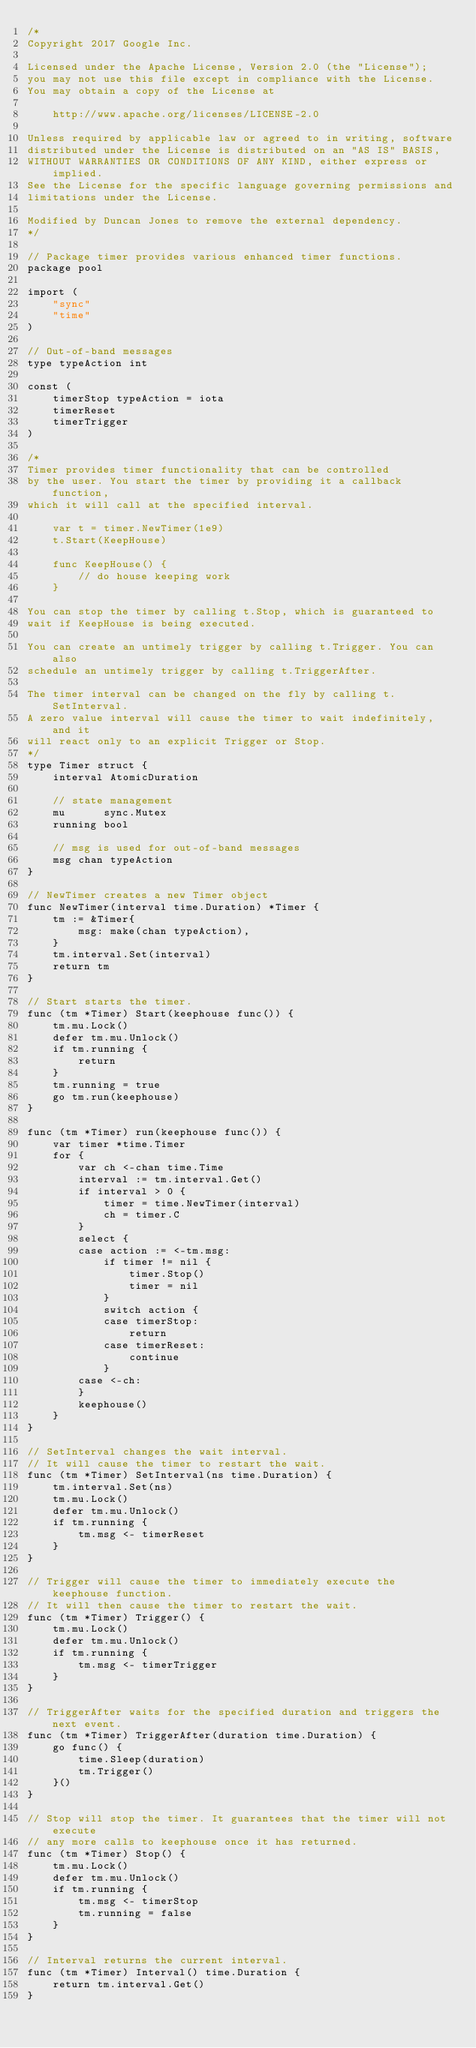<code> <loc_0><loc_0><loc_500><loc_500><_Go_>/*
Copyright 2017 Google Inc.

Licensed under the Apache License, Version 2.0 (the "License");
you may not use this file except in compliance with the License.
You may obtain a copy of the License at

    http://www.apache.org/licenses/LICENSE-2.0

Unless required by applicable law or agreed to in writing, software
distributed under the License is distributed on an "AS IS" BASIS,
WITHOUT WARRANTIES OR CONDITIONS OF ANY KIND, either express or implied.
See the License for the specific language governing permissions and
limitations under the License.

Modified by Duncan Jones to remove the external dependency.
*/

// Package timer provides various enhanced timer functions.
package pool

import (
	"sync"
	"time"
)

// Out-of-band messages
type typeAction int

const (
	timerStop typeAction = iota
	timerReset
	timerTrigger
)

/*
Timer provides timer functionality that can be controlled
by the user. You start the timer by providing it a callback function,
which it will call at the specified interval.

	var t = timer.NewTimer(1e9)
	t.Start(KeepHouse)

	func KeepHouse() {
		// do house keeping work
	}

You can stop the timer by calling t.Stop, which is guaranteed to
wait if KeepHouse is being executed.

You can create an untimely trigger by calling t.Trigger. You can also
schedule an untimely trigger by calling t.TriggerAfter.

The timer interval can be changed on the fly by calling t.SetInterval.
A zero value interval will cause the timer to wait indefinitely, and it
will react only to an explicit Trigger or Stop.
*/
type Timer struct {
	interval AtomicDuration

	// state management
	mu      sync.Mutex
	running bool

	// msg is used for out-of-band messages
	msg chan typeAction
}

// NewTimer creates a new Timer object
func NewTimer(interval time.Duration) *Timer {
	tm := &Timer{
		msg: make(chan typeAction),
	}
	tm.interval.Set(interval)
	return tm
}

// Start starts the timer.
func (tm *Timer) Start(keephouse func()) {
	tm.mu.Lock()
	defer tm.mu.Unlock()
	if tm.running {
		return
	}
	tm.running = true
	go tm.run(keephouse)
}

func (tm *Timer) run(keephouse func()) {
	var timer *time.Timer
	for {
		var ch <-chan time.Time
		interval := tm.interval.Get()
		if interval > 0 {
			timer = time.NewTimer(interval)
			ch = timer.C
		}
		select {
		case action := <-tm.msg:
			if timer != nil {
				timer.Stop()
				timer = nil
			}
			switch action {
			case timerStop:
				return
			case timerReset:
				continue
			}
		case <-ch:
		}
		keephouse()
	}
}

// SetInterval changes the wait interval.
// It will cause the timer to restart the wait.
func (tm *Timer) SetInterval(ns time.Duration) {
	tm.interval.Set(ns)
	tm.mu.Lock()
	defer tm.mu.Unlock()
	if tm.running {
		tm.msg <- timerReset
	}
}

// Trigger will cause the timer to immediately execute the keephouse function.
// It will then cause the timer to restart the wait.
func (tm *Timer) Trigger() {
	tm.mu.Lock()
	defer tm.mu.Unlock()
	if tm.running {
		tm.msg <- timerTrigger
	}
}

// TriggerAfter waits for the specified duration and triggers the next event.
func (tm *Timer) TriggerAfter(duration time.Duration) {
	go func() {
		time.Sleep(duration)
		tm.Trigger()
	}()
}

// Stop will stop the timer. It guarantees that the timer will not execute
// any more calls to keephouse once it has returned.
func (tm *Timer) Stop() {
	tm.mu.Lock()
	defer tm.mu.Unlock()
	if tm.running {
		tm.msg <- timerStop
		tm.running = false
	}
}

// Interval returns the current interval.
func (tm *Timer) Interval() time.Duration {
	return tm.interval.Get()
}
</code> 